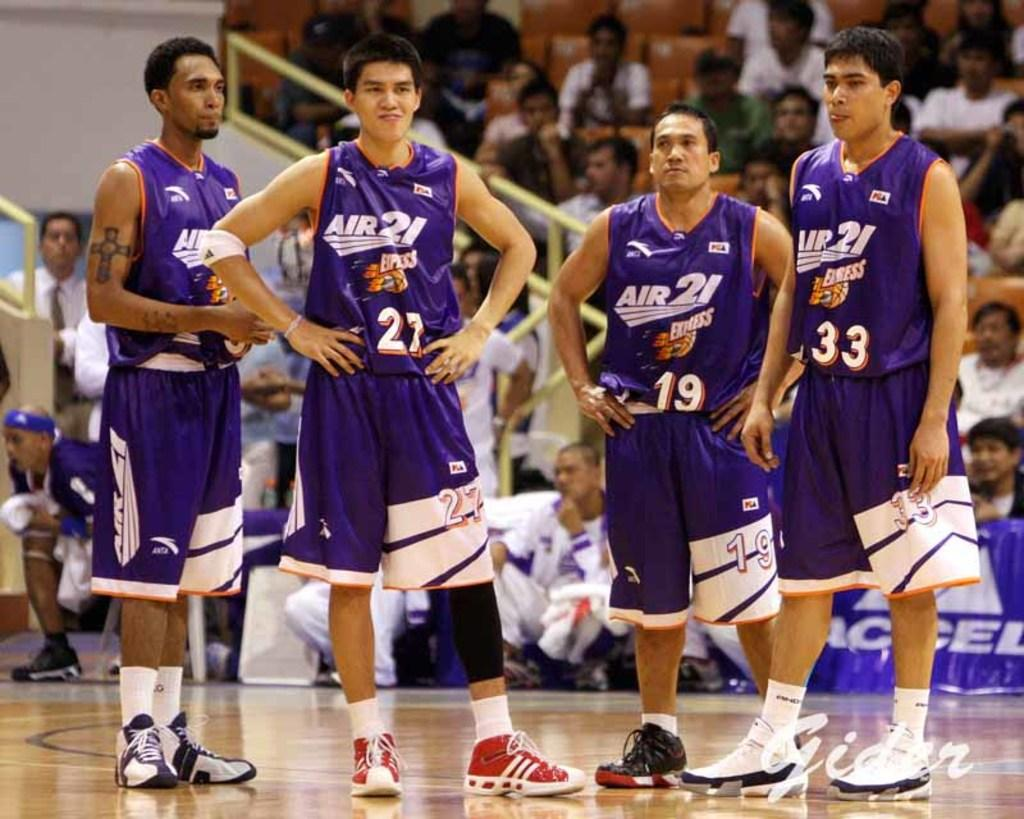Provide a one-sentence caption for the provided image. 4 men with jerseys that say air 21. 